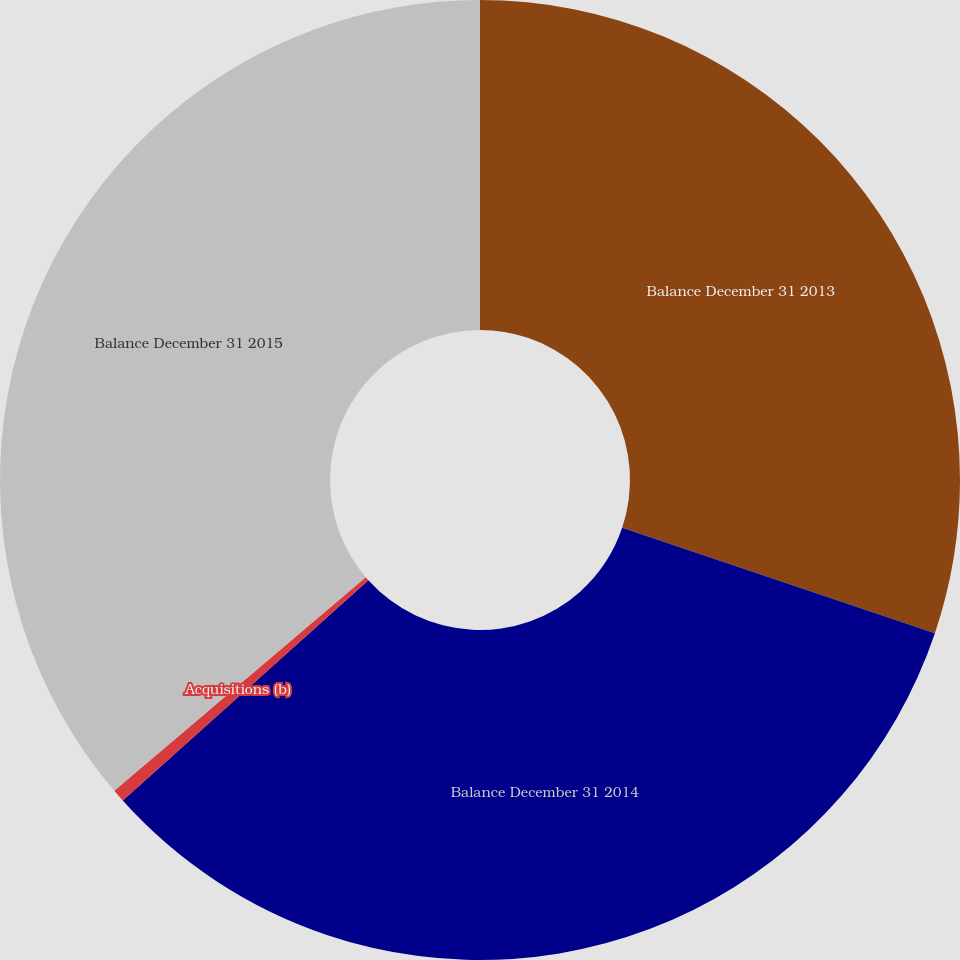Convert chart to OTSL. <chart><loc_0><loc_0><loc_500><loc_500><pie_chart><fcel>Balance December 31 2013<fcel>Balance December 31 2014<fcel>Acquisitions (b)<fcel>Balance December 31 2015<nl><fcel>30.17%<fcel>33.19%<fcel>0.43%<fcel>36.21%<nl></chart> 